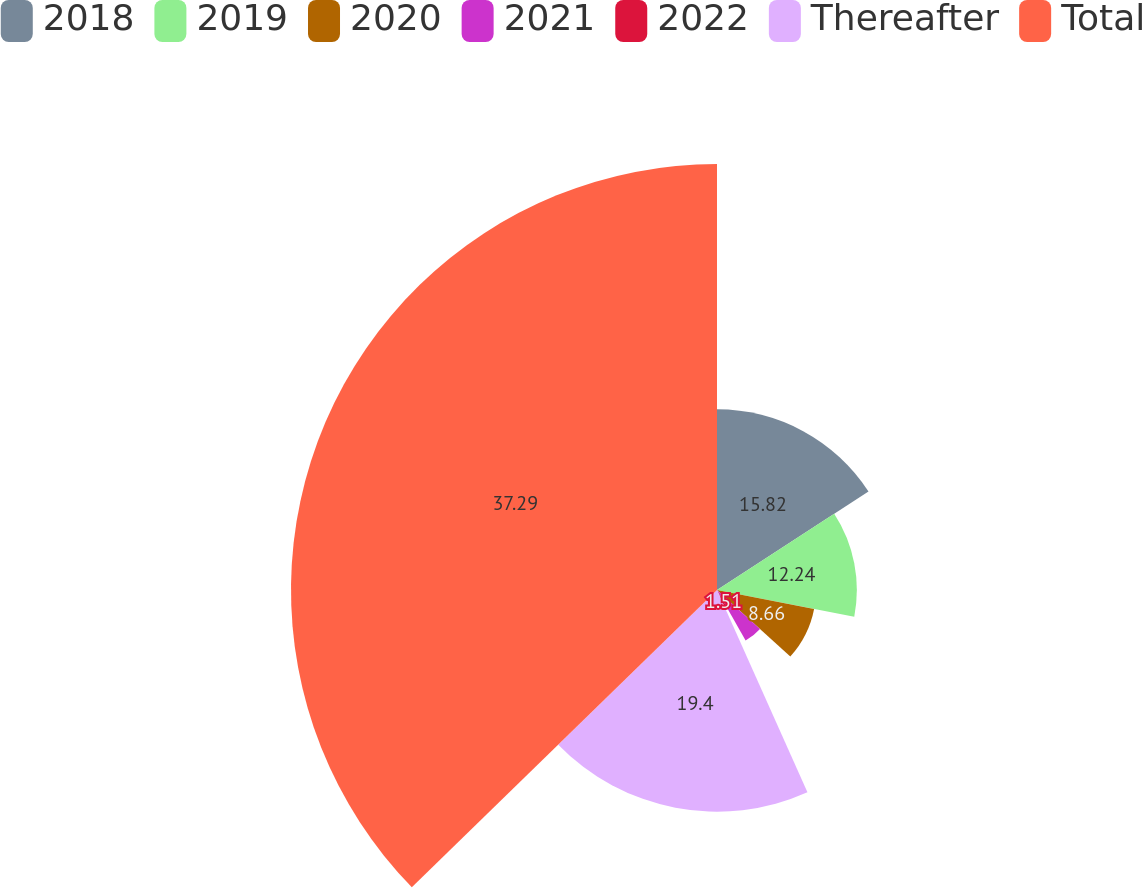Convert chart to OTSL. <chart><loc_0><loc_0><loc_500><loc_500><pie_chart><fcel>2018<fcel>2019<fcel>2020<fcel>2021<fcel>2022<fcel>Thereafter<fcel>Total<nl><fcel>15.82%<fcel>12.24%<fcel>8.66%<fcel>5.08%<fcel>1.51%<fcel>19.4%<fcel>37.29%<nl></chart> 